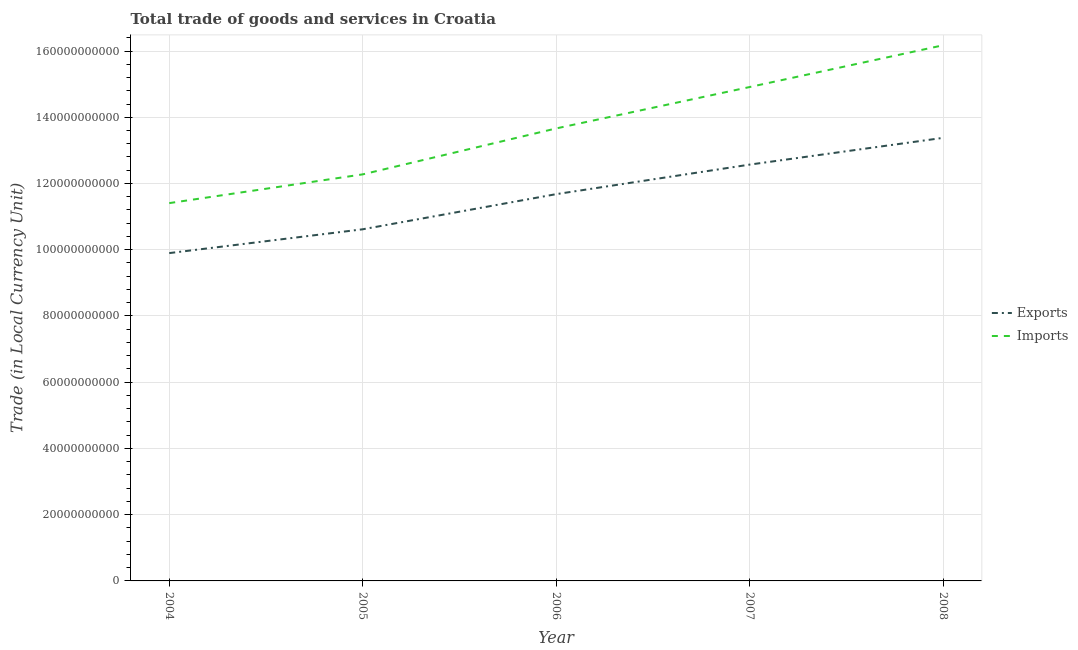Is the number of lines equal to the number of legend labels?
Offer a terse response. Yes. What is the imports of goods and services in 2004?
Provide a succinct answer. 1.14e+11. Across all years, what is the maximum export of goods and services?
Keep it short and to the point. 1.34e+11. Across all years, what is the minimum export of goods and services?
Ensure brevity in your answer.  9.90e+1. In which year was the export of goods and services minimum?
Your response must be concise. 2004. What is the total export of goods and services in the graph?
Your response must be concise. 5.81e+11. What is the difference between the imports of goods and services in 2005 and that in 2007?
Give a very brief answer. -2.64e+1. What is the difference between the export of goods and services in 2006 and the imports of goods and services in 2008?
Offer a terse response. -4.50e+1. What is the average imports of goods and services per year?
Offer a terse response. 1.37e+11. In the year 2006, what is the difference between the imports of goods and services and export of goods and services?
Offer a very short reply. 1.98e+1. In how many years, is the imports of goods and services greater than 148000000000 LCU?
Ensure brevity in your answer.  2. What is the ratio of the imports of goods and services in 2006 to that in 2007?
Make the answer very short. 0.92. What is the difference between the highest and the second highest imports of goods and services?
Offer a very short reply. 1.26e+1. What is the difference between the highest and the lowest imports of goods and services?
Offer a very short reply. 4.77e+1. In how many years, is the export of goods and services greater than the average export of goods and services taken over all years?
Your answer should be very brief. 3. Is the sum of the imports of goods and services in 2004 and 2007 greater than the maximum export of goods and services across all years?
Make the answer very short. Yes. Is the export of goods and services strictly less than the imports of goods and services over the years?
Make the answer very short. Yes. How many lines are there?
Keep it short and to the point. 2. Does the graph contain any zero values?
Provide a short and direct response. No. Does the graph contain grids?
Provide a succinct answer. Yes. Where does the legend appear in the graph?
Make the answer very short. Center right. How are the legend labels stacked?
Offer a terse response. Vertical. What is the title of the graph?
Offer a very short reply. Total trade of goods and services in Croatia. Does "Methane emissions" appear as one of the legend labels in the graph?
Your answer should be compact. No. What is the label or title of the Y-axis?
Keep it short and to the point. Trade (in Local Currency Unit). What is the Trade (in Local Currency Unit) in Exports in 2004?
Keep it short and to the point. 9.90e+1. What is the Trade (in Local Currency Unit) in Imports in 2004?
Offer a very short reply. 1.14e+11. What is the Trade (in Local Currency Unit) of Exports in 2005?
Ensure brevity in your answer.  1.06e+11. What is the Trade (in Local Currency Unit) in Imports in 2005?
Your response must be concise. 1.23e+11. What is the Trade (in Local Currency Unit) in Exports in 2006?
Keep it short and to the point. 1.17e+11. What is the Trade (in Local Currency Unit) of Imports in 2006?
Your answer should be compact. 1.37e+11. What is the Trade (in Local Currency Unit) of Exports in 2007?
Give a very brief answer. 1.26e+11. What is the Trade (in Local Currency Unit) of Imports in 2007?
Offer a very short reply. 1.49e+11. What is the Trade (in Local Currency Unit) of Exports in 2008?
Offer a terse response. 1.34e+11. What is the Trade (in Local Currency Unit) of Imports in 2008?
Offer a very short reply. 1.62e+11. Across all years, what is the maximum Trade (in Local Currency Unit) of Exports?
Offer a terse response. 1.34e+11. Across all years, what is the maximum Trade (in Local Currency Unit) in Imports?
Give a very brief answer. 1.62e+11. Across all years, what is the minimum Trade (in Local Currency Unit) in Exports?
Provide a succinct answer. 9.90e+1. Across all years, what is the minimum Trade (in Local Currency Unit) in Imports?
Make the answer very short. 1.14e+11. What is the total Trade (in Local Currency Unit) of Exports in the graph?
Offer a terse response. 5.81e+11. What is the total Trade (in Local Currency Unit) in Imports in the graph?
Your answer should be very brief. 6.84e+11. What is the difference between the Trade (in Local Currency Unit) of Exports in 2004 and that in 2005?
Your answer should be compact. -7.19e+09. What is the difference between the Trade (in Local Currency Unit) of Imports in 2004 and that in 2005?
Provide a short and direct response. -8.68e+09. What is the difference between the Trade (in Local Currency Unit) of Exports in 2004 and that in 2006?
Make the answer very short. -1.78e+1. What is the difference between the Trade (in Local Currency Unit) of Imports in 2004 and that in 2006?
Your answer should be compact. -2.26e+1. What is the difference between the Trade (in Local Currency Unit) in Exports in 2004 and that in 2007?
Your answer should be compact. -2.67e+1. What is the difference between the Trade (in Local Currency Unit) of Imports in 2004 and that in 2007?
Make the answer very short. -3.51e+1. What is the difference between the Trade (in Local Currency Unit) in Exports in 2004 and that in 2008?
Keep it short and to the point. -3.48e+1. What is the difference between the Trade (in Local Currency Unit) of Imports in 2004 and that in 2008?
Give a very brief answer. -4.77e+1. What is the difference between the Trade (in Local Currency Unit) of Exports in 2005 and that in 2006?
Your response must be concise. -1.06e+1. What is the difference between the Trade (in Local Currency Unit) in Imports in 2005 and that in 2006?
Your answer should be compact. -1.39e+1. What is the difference between the Trade (in Local Currency Unit) in Exports in 2005 and that in 2007?
Your answer should be compact. -1.95e+1. What is the difference between the Trade (in Local Currency Unit) in Imports in 2005 and that in 2007?
Make the answer very short. -2.64e+1. What is the difference between the Trade (in Local Currency Unit) in Exports in 2005 and that in 2008?
Provide a short and direct response. -2.76e+1. What is the difference between the Trade (in Local Currency Unit) of Imports in 2005 and that in 2008?
Offer a very short reply. -3.90e+1. What is the difference between the Trade (in Local Currency Unit) of Exports in 2006 and that in 2007?
Provide a succinct answer. -8.92e+09. What is the difference between the Trade (in Local Currency Unit) in Imports in 2006 and that in 2007?
Provide a short and direct response. -1.25e+1. What is the difference between the Trade (in Local Currency Unit) in Exports in 2006 and that in 2008?
Your answer should be very brief. -1.70e+1. What is the difference between the Trade (in Local Currency Unit) in Imports in 2006 and that in 2008?
Make the answer very short. -2.51e+1. What is the difference between the Trade (in Local Currency Unit) in Exports in 2007 and that in 2008?
Keep it short and to the point. -8.08e+09. What is the difference between the Trade (in Local Currency Unit) of Imports in 2007 and that in 2008?
Ensure brevity in your answer.  -1.26e+1. What is the difference between the Trade (in Local Currency Unit) in Exports in 2004 and the Trade (in Local Currency Unit) in Imports in 2005?
Your answer should be compact. -2.38e+1. What is the difference between the Trade (in Local Currency Unit) of Exports in 2004 and the Trade (in Local Currency Unit) of Imports in 2006?
Ensure brevity in your answer.  -3.76e+1. What is the difference between the Trade (in Local Currency Unit) in Exports in 2004 and the Trade (in Local Currency Unit) in Imports in 2007?
Your response must be concise. -5.01e+1. What is the difference between the Trade (in Local Currency Unit) in Exports in 2004 and the Trade (in Local Currency Unit) in Imports in 2008?
Make the answer very short. -6.28e+1. What is the difference between the Trade (in Local Currency Unit) in Exports in 2005 and the Trade (in Local Currency Unit) in Imports in 2006?
Offer a very short reply. -3.05e+1. What is the difference between the Trade (in Local Currency Unit) in Exports in 2005 and the Trade (in Local Currency Unit) in Imports in 2007?
Your answer should be compact. -4.30e+1. What is the difference between the Trade (in Local Currency Unit) in Exports in 2005 and the Trade (in Local Currency Unit) in Imports in 2008?
Offer a very short reply. -5.56e+1. What is the difference between the Trade (in Local Currency Unit) in Exports in 2006 and the Trade (in Local Currency Unit) in Imports in 2007?
Your answer should be compact. -3.23e+1. What is the difference between the Trade (in Local Currency Unit) of Exports in 2006 and the Trade (in Local Currency Unit) of Imports in 2008?
Give a very brief answer. -4.50e+1. What is the difference between the Trade (in Local Currency Unit) in Exports in 2007 and the Trade (in Local Currency Unit) in Imports in 2008?
Provide a short and direct response. -3.60e+1. What is the average Trade (in Local Currency Unit) in Exports per year?
Provide a short and direct response. 1.16e+11. What is the average Trade (in Local Currency Unit) of Imports per year?
Offer a very short reply. 1.37e+11. In the year 2004, what is the difference between the Trade (in Local Currency Unit) in Exports and Trade (in Local Currency Unit) in Imports?
Offer a terse response. -1.51e+1. In the year 2005, what is the difference between the Trade (in Local Currency Unit) in Exports and Trade (in Local Currency Unit) in Imports?
Keep it short and to the point. -1.66e+1. In the year 2006, what is the difference between the Trade (in Local Currency Unit) of Exports and Trade (in Local Currency Unit) of Imports?
Give a very brief answer. -1.98e+1. In the year 2007, what is the difference between the Trade (in Local Currency Unit) in Exports and Trade (in Local Currency Unit) in Imports?
Give a very brief answer. -2.34e+1. In the year 2008, what is the difference between the Trade (in Local Currency Unit) of Exports and Trade (in Local Currency Unit) of Imports?
Ensure brevity in your answer.  -2.80e+1. What is the ratio of the Trade (in Local Currency Unit) in Exports in 2004 to that in 2005?
Your answer should be compact. 0.93. What is the ratio of the Trade (in Local Currency Unit) in Imports in 2004 to that in 2005?
Ensure brevity in your answer.  0.93. What is the ratio of the Trade (in Local Currency Unit) in Exports in 2004 to that in 2006?
Provide a short and direct response. 0.85. What is the ratio of the Trade (in Local Currency Unit) in Imports in 2004 to that in 2006?
Ensure brevity in your answer.  0.83. What is the ratio of the Trade (in Local Currency Unit) of Exports in 2004 to that in 2007?
Your response must be concise. 0.79. What is the ratio of the Trade (in Local Currency Unit) of Imports in 2004 to that in 2007?
Provide a succinct answer. 0.76. What is the ratio of the Trade (in Local Currency Unit) in Exports in 2004 to that in 2008?
Offer a very short reply. 0.74. What is the ratio of the Trade (in Local Currency Unit) of Imports in 2004 to that in 2008?
Keep it short and to the point. 0.71. What is the ratio of the Trade (in Local Currency Unit) of Imports in 2005 to that in 2006?
Your answer should be very brief. 0.9. What is the ratio of the Trade (in Local Currency Unit) of Exports in 2005 to that in 2007?
Ensure brevity in your answer.  0.84. What is the ratio of the Trade (in Local Currency Unit) in Imports in 2005 to that in 2007?
Your answer should be very brief. 0.82. What is the ratio of the Trade (in Local Currency Unit) in Exports in 2005 to that in 2008?
Your answer should be compact. 0.79. What is the ratio of the Trade (in Local Currency Unit) of Imports in 2005 to that in 2008?
Ensure brevity in your answer.  0.76. What is the ratio of the Trade (in Local Currency Unit) of Exports in 2006 to that in 2007?
Make the answer very short. 0.93. What is the ratio of the Trade (in Local Currency Unit) in Imports in 2006 to that in 2007?
Make the answer very short. 0.92. What is the ratio of the Trade (in Local Currency Unit) in Exports in 2006 to that in 2008?
Your response must be concise. 0.87. What is the ratio of the Trade (in Local Currency Unit) of Imports in 2006 to that in 2008?
Provide a short and direct response. 0.84. What is the ratio of the Trade (in Local Currency Unit) in Exports in 2007 to that in 2008?
Offer a terse response. 0.94. What is the ratio of the Trade (in Local Currency Unit) in Imports in 2007 to that in 2008?
Ensure brevity in your answer.  0.92. What is the difference between the highest and the second highest Trade (in Local Currency Unit) in Exports?
Offer a very short reply. 8.08e+09. What is the difference between the highest and the second highest Trade (in Local Currency Unit) of Imports?
Offer a very short reply. 1.26e+1. What is the difference between the highest and the lowest Trade (in Local Currency Unit) of Exports?
Ensure brevity in your answer.  3.48e+1. What is the difference between the highest and the lowest Trade (in Local Currency Unit) in Imports?
Provide a short and direct response. 4.77e+1. 